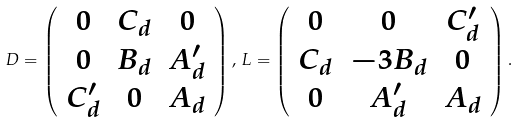<formula> <loc_0><loc_0><loc_500><loc_500>D = \left ( \begin{array} { c c c } 0 & C _ { d } & 0 \\ 0 & B _ { d } & A ^ { \prime } _ { d } \\ C ^ { \prime } _ { d } & 0 & A _ { d } \end{array} \right ) , \, L = \left ( \begin{array} { c c c } 0 & 0 & C ^ { \prime } _ { d } \\ C _ { d } & - 3 B _ { d } & 0 \\ 0 & A ^ { \prime } _ { d } & A _ { d } \end{array} \right ) .</formula> 